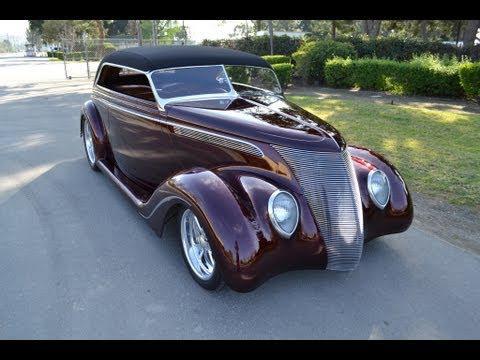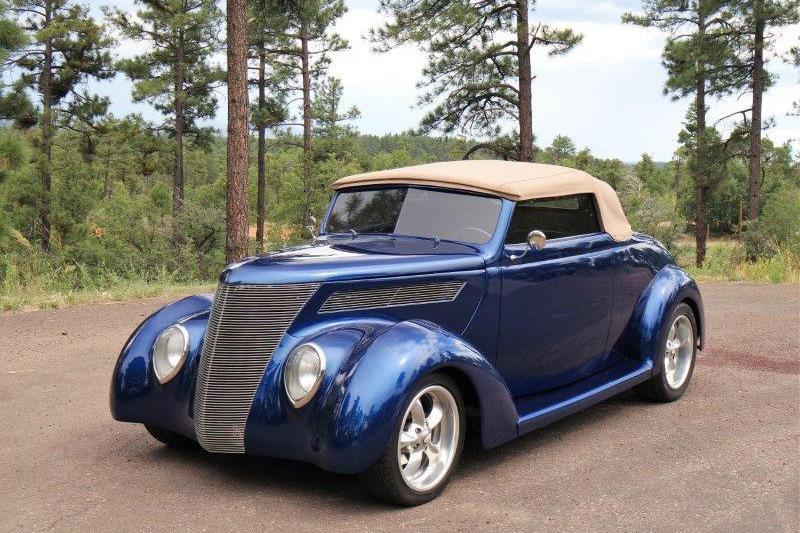The first image is the image on the left, the second image is the image on the right. Analyze the images presented: Is the assertion "The foreground cars in the left and right images face the same direction, and the righthand car is parked on a paved strip surrounded by grass and has a royal blue hood with a silver body." valid? Answer yes or no. No. The first image is the image on the left, the second image is the image on the right. Evaluate the accuracy of this statement regarding the images: "One car has a tan roof". Is it true? Answer yes or no. Yes. 